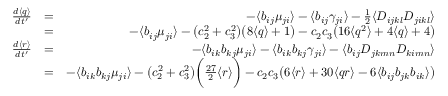<formula> <loc_0><loc_0><loc_500><loc_500>\begin{array} { r l r } { \frac { d \langle q \rangle } { d t ^ { \prime } } } & { = } & { - \langle b _ { i j } \mu _ { j i } \rangle - \langle b _ { i j } \gamma _ { j i } \rangle - \frac { 1 } { 2 } \langle D _ { i j k l } D _ { j i k l } \rangle } \\ & { = } & { - \langle b _ { i j } \mu _ { j i } \rangle - \left ( c _ { 2 } ^ { 2 } + c _ { 3 } ^ { 2 } \right ) \left ( 8 \langle q \rangle + 1 \right ) - c _ { 2 } c _ { 3 } \left ( 1 6 \langle q ^ { 2 } \rangle + 4 \langle q \rangle + 4 \right ) } \\ { \frac { d \langle r \rangle } { d t ^ { \prime } } } & { = } & { - \langle b _ { i k } b _ { k j } \mu _ { j i } \rangle - \langle b _ { i k } b _ { k j } \gamma _ { j i } \rangle - \langle b _ { i j } D _ { j k m n } D _ { k i m n } \rangle } \\ & { = } & { - \langle b _ { i k } b _ { k j } \mu _ { j i } \rangle - \left ( c _ { 2 } ^ { 2 } + c _ { 3 } ^ { 2 } \right ) \left ( \frac { 2 7 } { 2 } \langle r \rangle \right ) - c _ { 2 } c _ { 3 } \left ( 6 \langle r \rangle + 3 0 \langle q r \rangle - 6 \langle b _ { i j } b _ { j k } b _ { i k } \rangle \right ) } \end{array}</formula> 